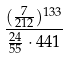Convert formula to latex. <formula><loc_0><loc_0><loc_500><loc_500>\frac { ( \frac { 7 } { 2 1 2 } ) ^ { 1 3 3 } } { \frac { 2 4 } { 5 5 } \cdot 4 4 1 }</formula> 